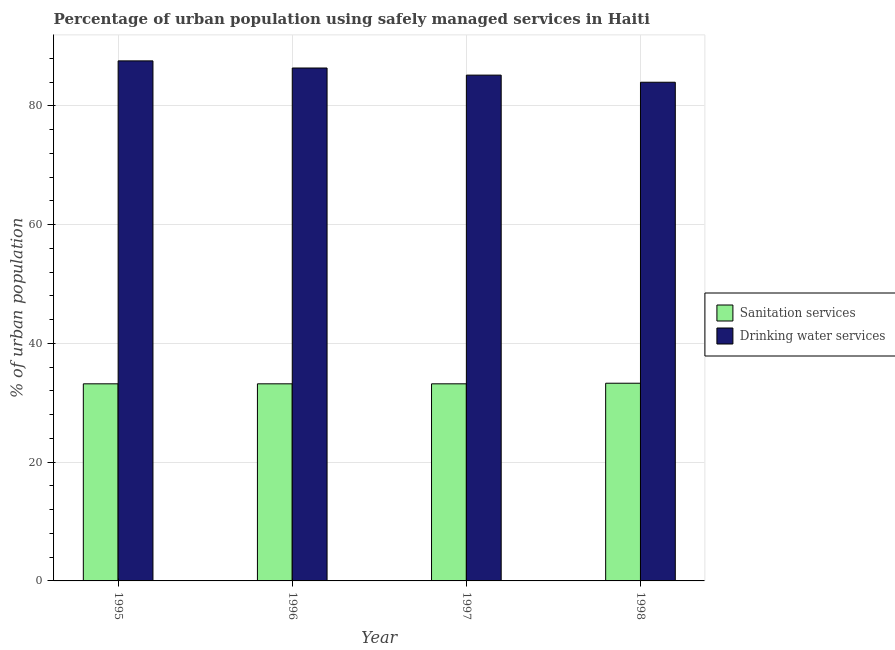How many different coloured bars are there?
Make the answer very short. 2. How many groups of bars are there?
Your response must be concise. 4. Are the number of bars per tick equal to the number of legend labels?
Provide a short and direct response. Yes. What is the label of the 4th group of bars from the left?
Make the answer very short. 1998. What is the percentage of urban population who used drinking water services in 1996?
Your answer should be compact. 86.4. Across all years, what is the maximum percentage of urban population who used drinking water services?
Provide a succinct answer. 87.6. Across all years, what is the minimum percentage of urban population who used drinking water services?
Make the answer very short. 84. In which year was the percentage of urban population who used sanitation services maximum?
Keep it short and to the point. 1998. In which year was the percentage of urban population who used drinking water services minimum?
Make the answer very short. 1998. What is the total percentage of urban population who used drinking water services in the graph?
Provide a short and direct response. 343.2. What is the difference between the percentage of urban population who used drinking water services in 1996 and that in 1997?
Provide a short and direct response. 1.2. What is the average percentage of urban population who used sanitation services per year?
Your answer should be very brief. 33.23. In the year 1998, what is the difference between the percentage of urban population who used sanitation services and percentage of urban population who used drinking water services?
Ensure brevity in your answer.  0. Is the percentage of urban population who used drinking water services in 1995 less than that in 1997?
Provide a short and direct response. No. Is the difference between the percentage of urban population who used drinking water services in 1996 and 1998 greater than the difference between the percentage of urban population who used sanitation services in 1996 and 1998?
Ensure brevity in your answer.  No. What is the difference between the highest and the second highest percentage of urban population who used drinking water services?
Provide a short and direct response. 1.2. What is the difference between the highest and the lowest percentage of urban population who used sanitation services?
Offer a terse response. 0.1. In how many years, is the percentage of urban population who used drinking water services greater than the average percentage of urban population who used drinking water services taken over all years?
Provide a succinct answer. 2. What does the 2nd bar from the left in 1997 represents?
Your response must be concise. Drinking water services. What does the 2nd bar from the right in 1998 represents?
Offer a very short reply. Sanitation services. Are the values on the major ticks of Y-axis written in scientific E-notation?
Ensure brevity in your answer.  No. Does the graph contain any zero values?
Ensure brevity in your answer.  No. How many legend labels are there?
Provide a short and direct response. 2. How are the legend labels stacked?
Make the answer very short. Vertical. What is the title of the graph?
Your answer should be compact. Percentage of urban population using safely managed services in Haiti. What is the label or title of the Y-axis?
Your response must be concise. % of urban population. What is the % of urban population of Sanitation services in 1995?
Provide a short and direct response. 33.2. What is the % of urban population of Drinking water services in 1995?
Offer a very short reply. 87.6. What is the % of urban population of Sanitation services in 1996?
Give a very brief answer. 33.2. What is the % of urban population of Drinking water services in 1996?
Provide a short and direct response. 86.4. What is the % of urban population in Sanitation services in 1997?
Provide a short and direct response. 33.2. What is the % of urban population of Drinking water services in 1997?
Your response must be concise. 85.2. What is the % of urban population in Sanitation services in 1998?
Your answer should be very brief. 33.3. Across all years, what is the maximum % of urban population in Sanitation services?
Your answer should be very brief. 33.3. Across all years, what is the maximum % of urban population in Drinking water services?
Your response must be concise. 87.6. Across all years, what is the minimum % of urban population in Sanitation services?
Your response must be concise. 33.2. What is the total % of urban population of Sanitation services in the graph?
Make the answer very short. 132.9. What is the total % of urban population of Drinking water services in the graph?
Provide a short and direct response. 343.2. What is the difference between the % of urban population of Drinking water services in 1995 and that in 1996?
Your answer should be very brief. 1.2. What is the difference between the % of urban population in Sanitation services in 1995 and that in 1997?
Provide a short and direct response. 0. What is the difference between the % of urban population in Drinking water services in 1995 and that in 1997?
Your answer should be compact. 2.4. What is the difference between the % of urban population in Sanitation services in 1996 and that in 1998?
Your answer should be very brief. -0.1. What is the difference between the % of urban population of Drinking water services in 1996 and that in 1998?
Offer a very short reply. 2.4. What is the difference between the % of urban population of Drinking water services in 1997 and that in 1998?
Keep it short and to the point. 1.2. What is the difference between the % of urban population of Sanitation services in 1995 and the % of urban population of Drinking water services in 1996?
Offer a very short reply. -53.2. What is the difference between the % of urban population of Sanitation services in 1995 and the % of urban population of Drinking water services in 1997?
Offer a terse response. -52. What is the difference between the % of urban population in Sanitation services in 1995 and the % of urban population in Drinking water services in 1998?
Offer a very short reply. -50.8. What is the difference between the % of urban population of Sanitation services in 1996 and the % of urban population of Drinking water services in 1997?
Keep it short and to the point. -52. What is the difference between the % of urban population of Sanitation services in 1996 and the % of urban population of Drinking water services in 1998?
Provide a succinct answer. -50.8. What is the difference between the % of urban population of Sanitation services in 1997 and the % of urban population of Drinking water services in 1998?
Keep it short and to the point. -50.8. What is the average % of urban population in Sanitation services per year?
Your answer should be compact. 33.23. What is the average % of urban population of Drinking water services per year?
Give a very brief answer. 85.8. In the year 1995, what is the difference between the % of urban population of Sanitation services and % of urban population of Drinking water services?
Ensure brevity in your answer.  -54.4. In the year 1996, what is the difference between the % of urban population in Sanitation services and % of urban population in Drinking water services?
Your answer should be compact. -53.2. In the year 1997, what is the difference between the % of urban population of Sanitation services and % of urban population of Drinking water services?
Offer a terse response. -52. In the year 1998, what is the difference between the % of urban population of Sanitation services and % of urban population of Drinking water services?
Provide a succinct answer. -50.7. What is the ratio of the % of urban population in Drinking water services in 1995 to that in 1996?
Your response must be concise. 1.01. What is the ratio of the % of urban population of Drinking water services in 1995 to that in 1997?
Ensure brevity in your answer.  1.03. What is the ratio of the % of urban population of Drinking water services in 1995 to that in 1998?
Offer a terse response. 1.04. What is the ratio of the % of urban population of Drinking water services in 1996 to that in 1997?
Provide a succinct answer. 1.01. What is the ratio of the % of urban population of Drinking water services in 1996 to that in 1998?
Give a very brief answer. 1.03. What is the ratio of the % of urban population of Drinking water services in 1997 to that in 1998?
Provide a short and direct response. 1.01. What is the difference between the highest and the second highest % of urban population in Sanitation services?
Keep it short and to the point. 0.1. What is the difference between the highest and the second highest % of urban population of Drinking water services?
Give a very brief answer. 1.2. 